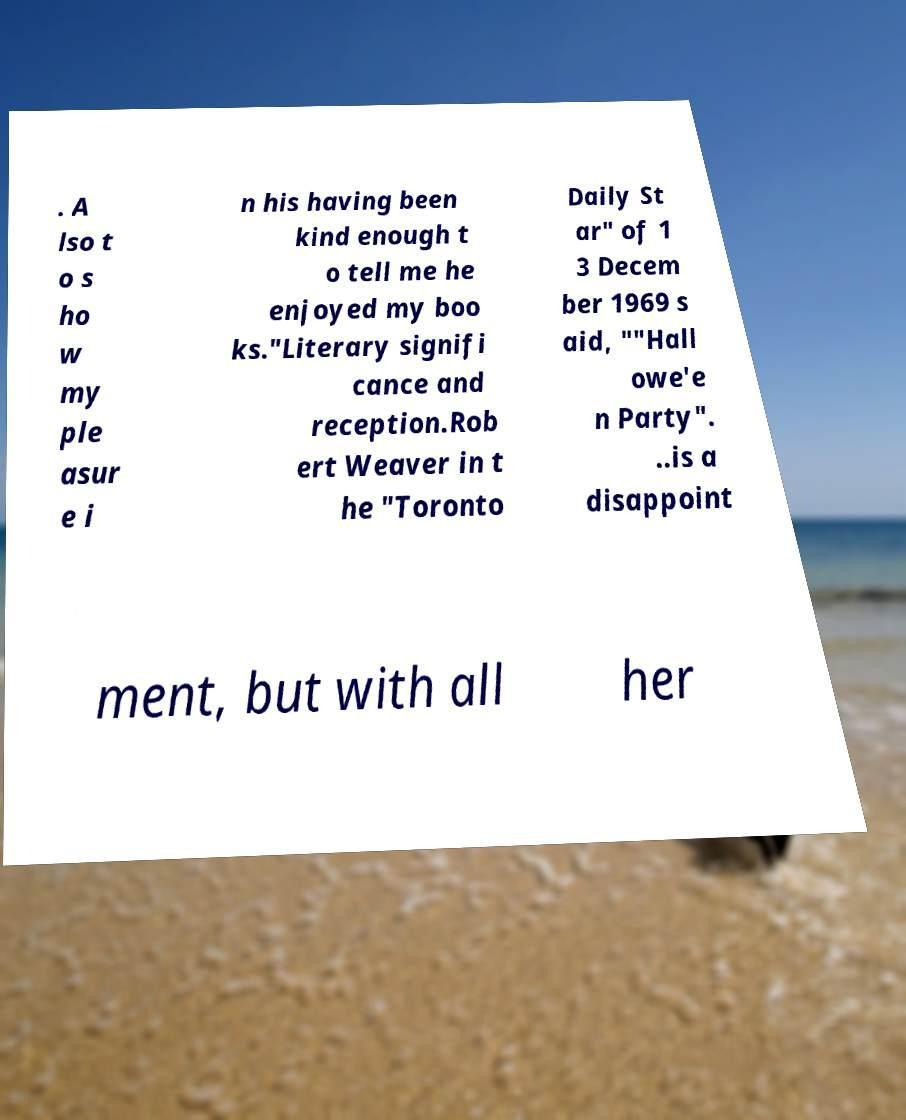Please read and relay the text visible in this image. What does it say? . A lso t o s ho w my ple asur e i n his having been kind enough t o tell me he enjoyed my boo ks."Literary signifi cance and reception.Rob ert Weaver in t he "Toronto Daily St ar" of 1 3 Decem ber 1969 s aid, ""Hall owe'e n Party". ..is a disappoint ment, but with all her 